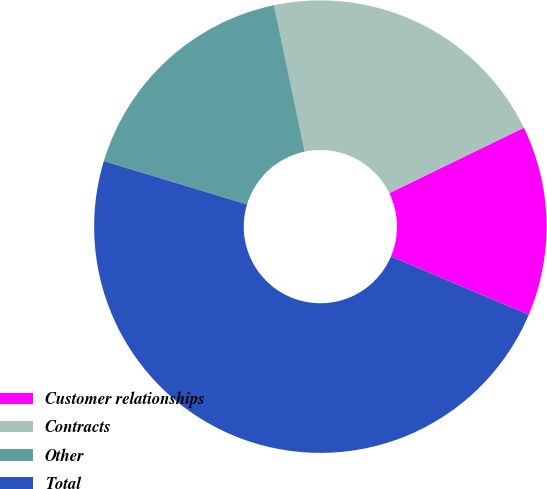<chart> <loc_0><loc_0><loc_500><loc_500><pie_chart><fcel>Customer relationships<fcel>Contracts<fcel>Other<fcel>Total<nl><fcel>13.57%<fcel>21.08%<fcel>17.04%<fcel>48.31%<nl></chart> 